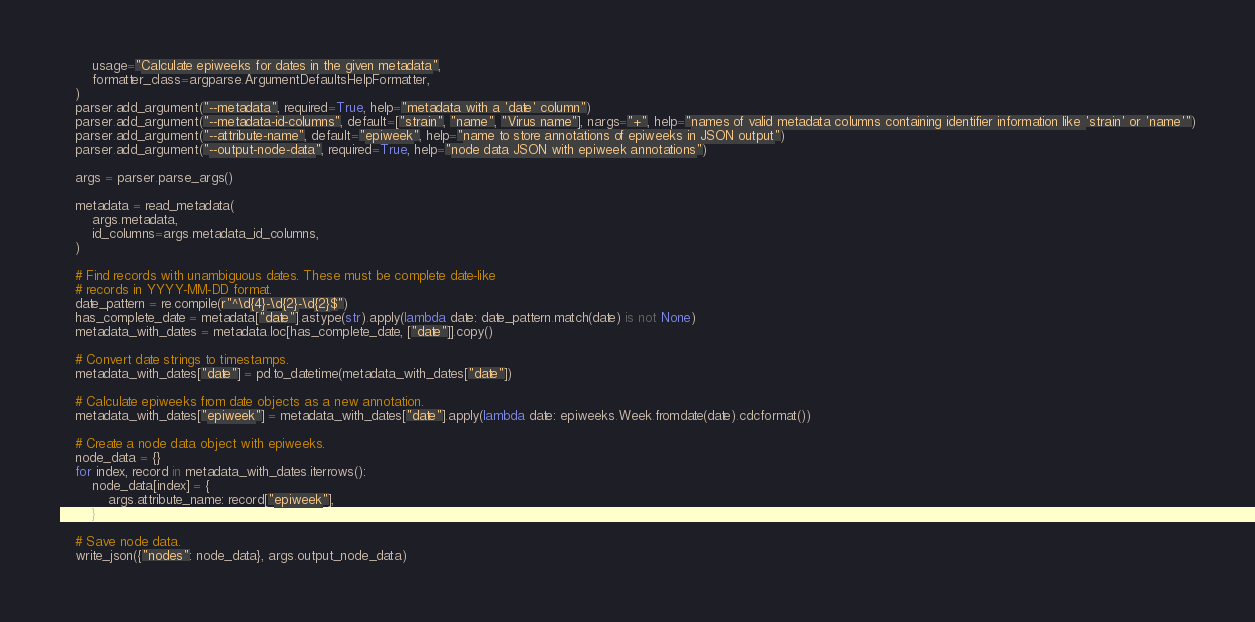<code> <loc_0><loc_0><loc_500><loc_500><_Python_>        usage="Calculate epiweeks for dates in the given metadata",
        formatter_class=argparse.ArgumentDefaultsHelpFormatter,
    )
    parser.add_argument("--metadata", required=True, help="metadata with a 'date' column")
    parser.add_argument("--metadata-id-columns", default=["strain", "name", "Virus name"], nargs="+", help="names of valid metadata columns containing identifier information like 'strain' or 'name'")
    parser.add_argument("--attribute-name", default="epiweek", help="name to store annotations of epiweeks in JSON output")
    parser.add_argument("--output-node-data", required=True, help="node data JSON with epiweek annotations")

    args = parser.parse_args()

    metadata = read_metadata(
        args.metadata,
        id_columns=args.metadata_id_columns,
    )

    # Find records with unambiguous dates. These must be complete date-like
    # records in YYYY-MM-DD format.
    date_pattern = re.compile(r"^\d{4}-\d{2}-\d{2}$")
    has_complete_date = metadata["date"].astype(str).apply(lambda date: date_pattern.match(date) is not None)
    metadata_with_dates = metadata.loc[has_complete_date, ["date"]].copy()

    # Convert date strings to timestamps.
    metadata_with_dates["date"] = pd.to_datetime(metadata_with_dates["date"])

    # Calculate epiweeks from date objects as a new annotation.
    metadata_with_dates["epiweek"] = metadata_with_dates["date"].apply(lambda date: epiweeks.Week.fromdate(date).cdcformat())

    # Create a node data object with epiweeks.
    node_data = {}
    for index, record in metadata_with_dates.iterrows():
        node_data[index] = {
            args.attribute_name: record["epiweek"],
        }

    # Save node data.
    write_json({"nodes": node_data}, args.output_node_data)
</code> 